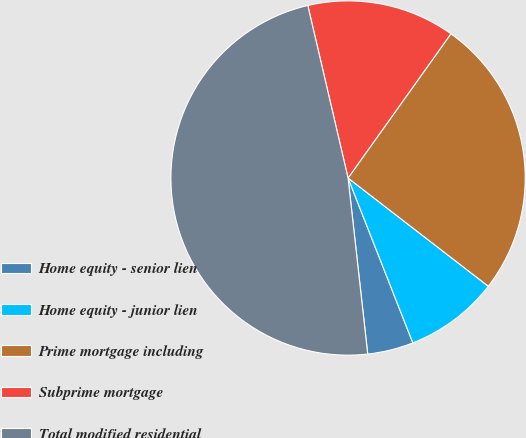<chart> <loc_0><loc_0><loc_500><loc_500><pie_chart><fcel>Home equity - senior lien<fcel>Home equity - junior lien<fcel>Prime mortgage including<fcel>Subprime mortgage<fcel>Total modified residential<nl><fcel>4.19%<fcel>8.58%<fcel>25.6%<fcel>13.51%<fcel>48.12%<nl></chart> 